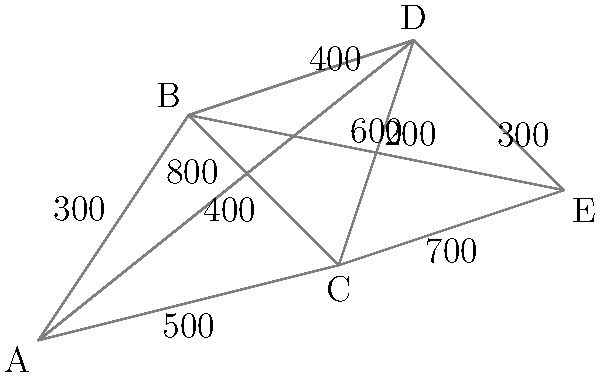As a software engineer developing a travel management system, you need to implement an algorithm to find the shortest route between cities A and E. Given the map above with distances (in km) between connected cities, what is the length of the shortest path from A to E? To find the shortest path from A to E, we need to consider all possible routes and calculate their total distances. Let's break it down step-by-step:

1. Identify all possible routes from A to E:
   - A -> B -> C -> D -> E
   - A -> B -> C -> E
   - A -> B -> D -> E
   - A -> B -> E
   - A -> C -> D -> E
   - A -> C -> E
   - A -> D -> E

2. Calculate the distance for each route:
   - A -> B -> C -> D -> E = 300 + 400 + 200 + 300 = 1200 km
   - A -> B -> C -> E = 300 + 400 + 700 = 1400 km
   - A -> B -> D -> E = 300 + 400 + 300 = 1000 km
   - A -> B -> E = 300 + 600 = 900 km
   - A -> C -> D -> E = 500 + 200 + 300 = 1000 km
   - A -> C -> E = 500 + 700 = 1200 km
   - A -> D -> E = 800 + 300 = 1100 km

3. Compare the distances to find the shortest route:
   The shortest route is A -> B -> E, with a total distance of 900 km.

Therefore, the length of the shortest path from A to E is 900 km.
Answer: 900 km 